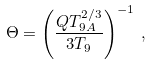Convert formula to latex. <formula><loc_0><loc_0><loc_500><loc_500>\Theta = \left ( \frac { Q T _ { 9 A } ^ { 2 / 3 } } { 3 T _ { 9 } } \right ) ^ { - 1 } \, ,</formula> 